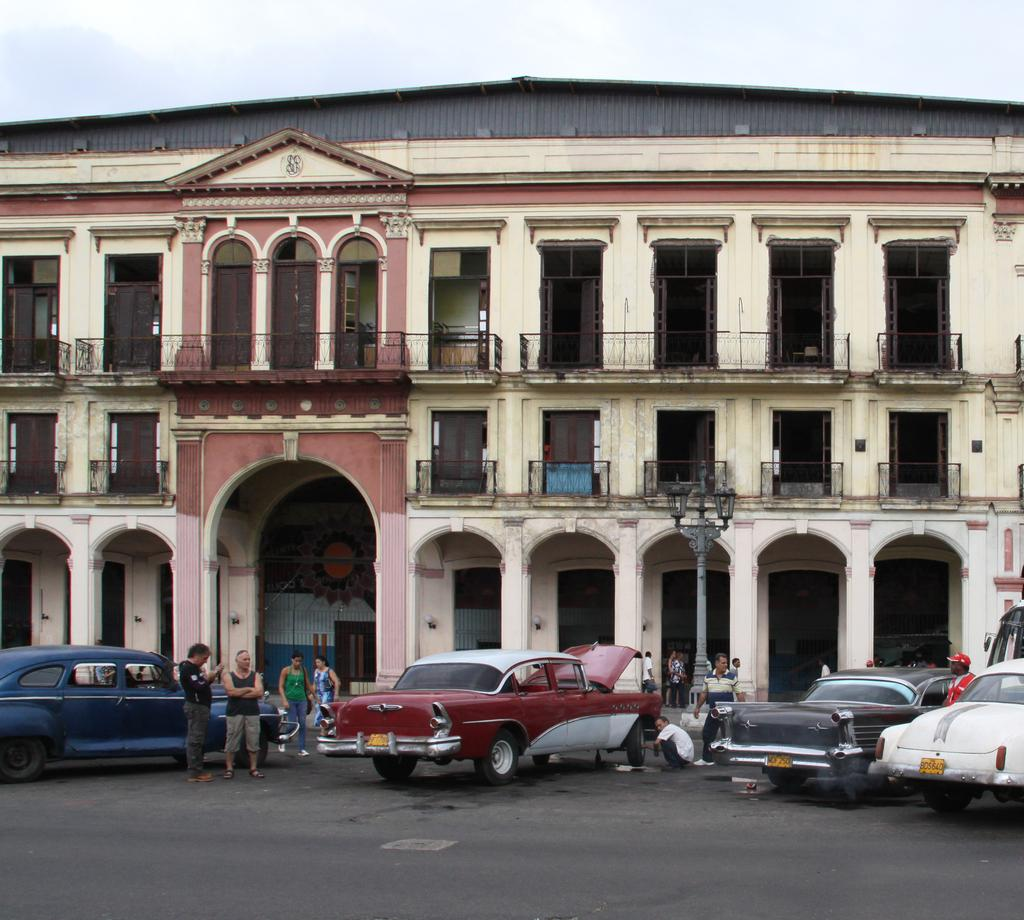What type of structure is present in the image? There is a building in the image. What is located near the building? There is a fence in the image. What else can be seen in the image besides the building and fence? There are vehicles and people in the image. What is attached to a pole in the image? There are lights on a pole in the image. What can be seen beneath the people and vehicles in the image? The ground is visible in the image. What is visible above the building and fence in the image? The sky is visible in the image. How many dimes are scattered on the ground in the image? There are no dimes present in the image; the ground is visible but no coins are mentioned. What type of property does the company own in the image? There is no mention of a company or property in the image; it features a building, fence, vehicles, people, lights, and the sky. 